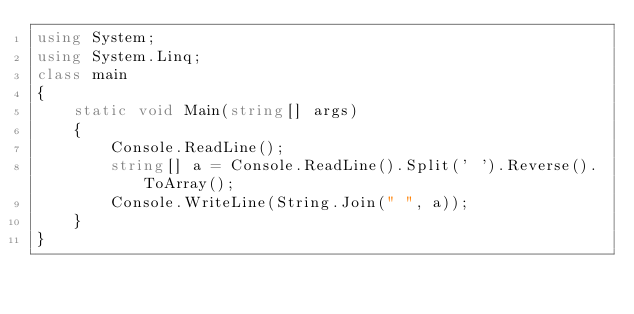Convert code to text. <code><loc_0><loc_0><loc_500><loc_500><_C#_>using System;
using System.Linq;
class main
{
    static void Main(string[] args)
    {
        Console.ReadLine();
        string[] a = Console.ReadLine().Split(' ').Reverse().ToArray();
        Console.WriteLine(String.Join(" ", a));
    }
}</code> 